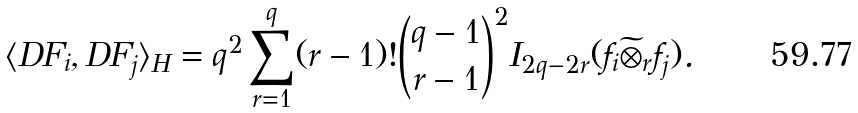Convert formula to latex. <formula><loc_0><loc_0><loc_500><loc_500>\langle D F _ { i } , D F _ { j } \rangle _ { H } = q ^ { 2 } \sum _ { r = 1 } ^ { q } ( r - 1 ) ! \binom { q - 1 } { r - 1 } ^ { 2 } I _ { 2 q - 2 r } ( f _ { i } \widetilde { \otimes } _ { r } f _ { j } ) .</formula> 